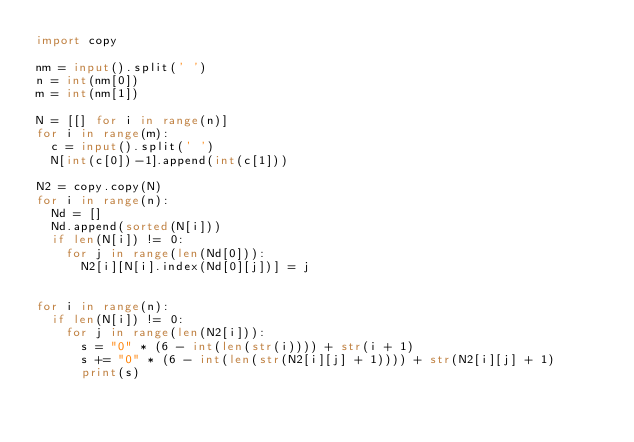Convert code to text. <code><loc_0><loc_0><loc_500><loc_500><_Python_>import copy

nm = input().split(' ')
n = int(nm[0])
m = int(nm[1])

N = [[] for i in range(n)]
for i in range(m):
  c = input().split(' ')
  N[int(c[0])-1].append(int(c[1]))
  
N2 = copy.copy(N)
for i in range(n):
  Nd = []
  Nd.append(sorted(N[i]))
  if len(N[i]) != 0:
    for j in range(len(Nd[0])):
      N2[i][N[i].index(Nd[0][j])] = j


for i in range(n):
  if len(N[i]) != 0:
    for j in range(len(N2[i])):
      s = "0" * (6 - int(len(str(i)))) + str(i + 1)
      s += "0" * (6 - int(len(str(N2[i][j] + 1)))) + str(N2[i][j] + 1)
      print(s)</code> 